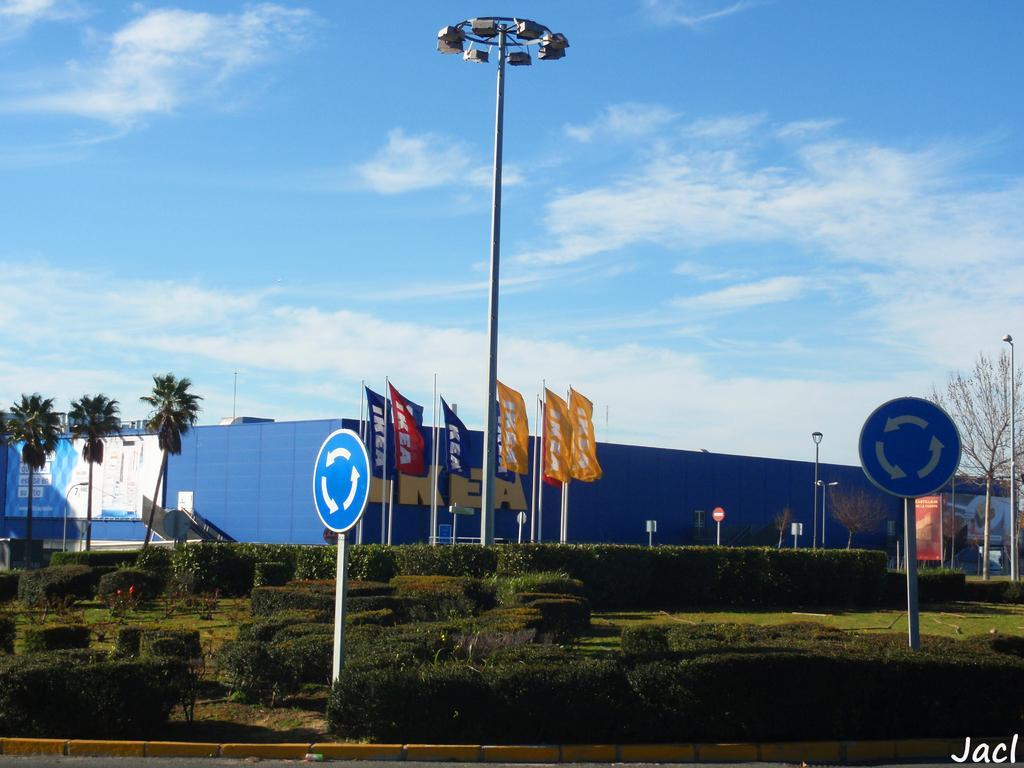Please provide a concise description of this image. In the center of the image we can see poles, flags, trees, boards, bushes, grass are there. At the bottom of the image we can see bricks, road are there. At the top of the image we can see lights, clouds are present in the sky. 